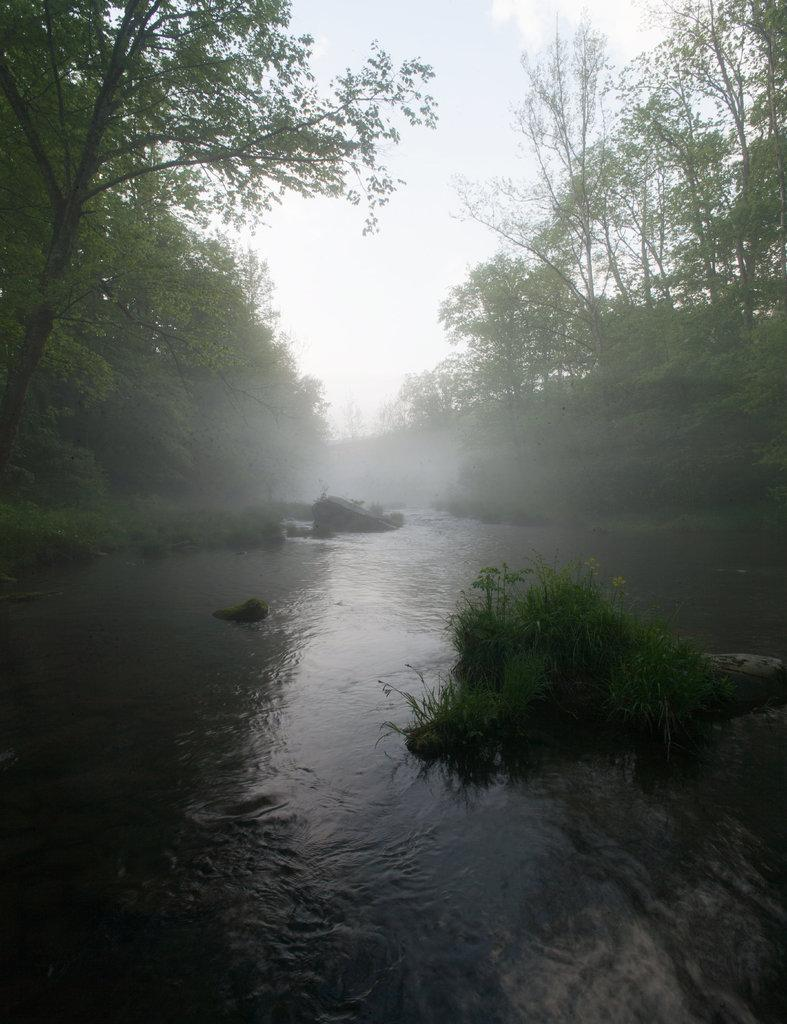What is present at the bottom of the image? There is water at the bottom side of the image. What can be seen in the background of the image? There is greenery in the background area of the image. Can you see a tail in the image? There is no tail present in the image. Is there a knife visible in the image? There is no knife present in the image. 